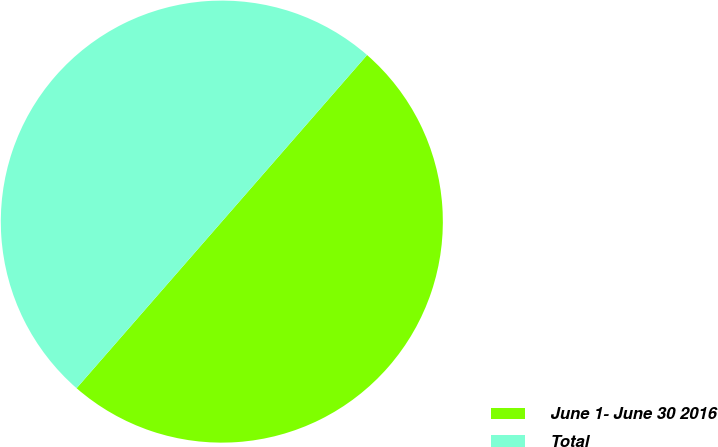<chart> <loc_0><loc_0><loc_500><loc_500><pie_chart><fcel>June 1- June 30 2016<fcel>Total<nl><fcel>50.0%<fcel>50.0%<nl></chart> 